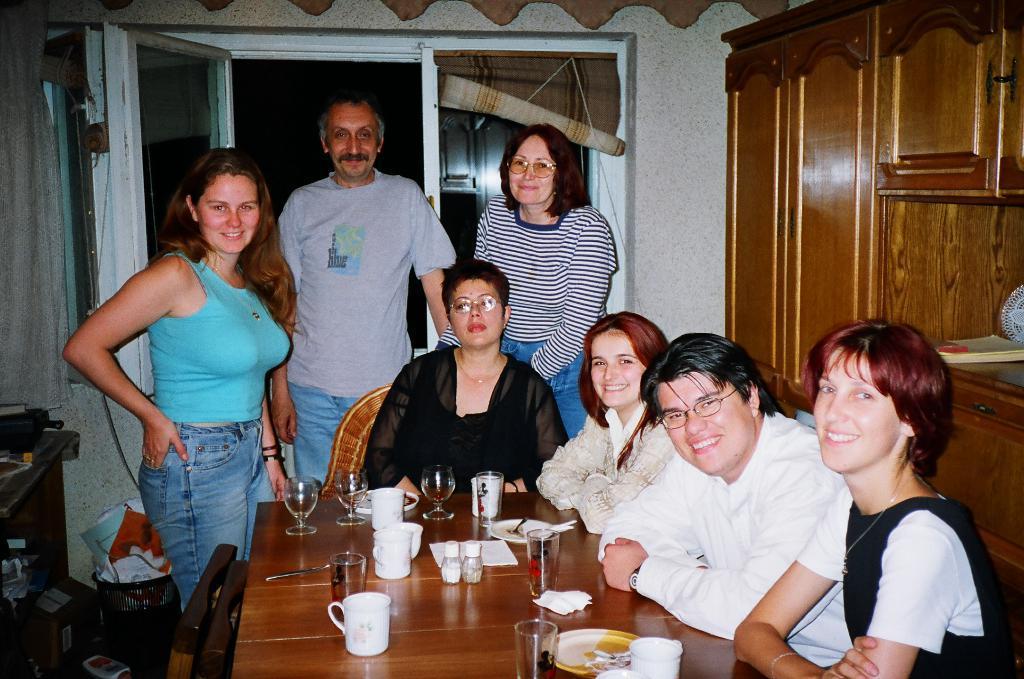Can you describe this image briefly? In the center of the image there are four people sitting around a dining table behind them there are three people standing. In the background there is a door and a curtain. On the left side of the room there is a bin. On the right side there is a cupboard. There are glasses, cups, spoons and plates placed on the table. 